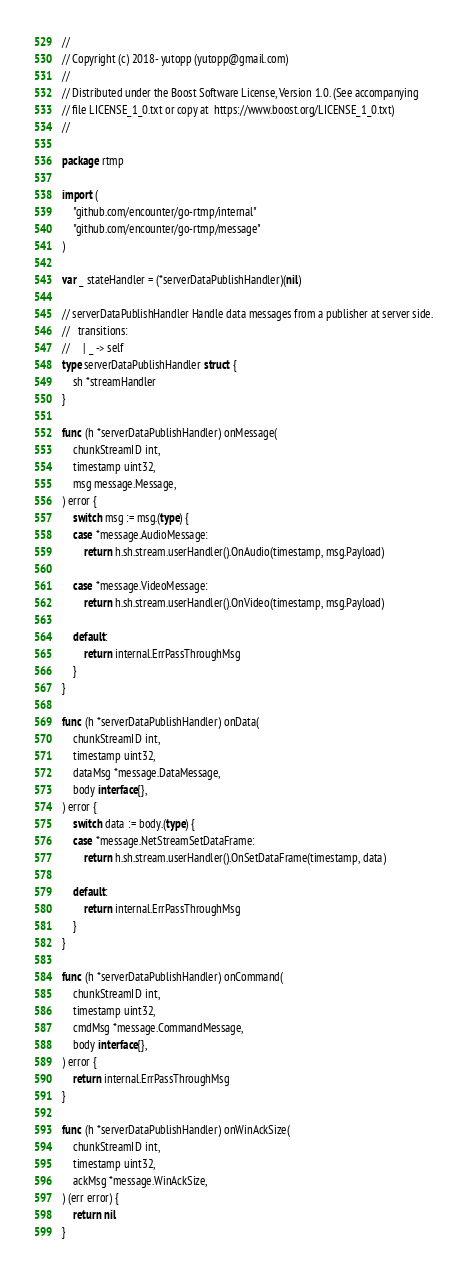Convert code to text. <code><loc_0><loc_0><loc_500><loc_500><_Go_>//
// Copyright (c) 2018- yutopp (yutopp@gmail.com)
//
// Distributed under the Boost Software License, Version 1.0. (See accompanying
// file LICENSE_1_0.txt or copy at  https://www.boost.org/LICENSE_1_0.txt)
//

package rtmp

import (
	"github.com/encounter/go-rtmp/internal"
	"github.com/encounter/go-rtmp/message"
)

var _ stateHandler = (*serverDataPublishHandler)(nil)

// serverDataPublishHandler Handle data messages from a publisher at server side.
//   transitions:
//     | _ -> self
type serverDataPublishHandler struct {
	sh *streamHandler
}

func (h *serverDataPublishHandler) onMessage(
	chunkStreamID int,
	timestamp uint32,
	msg message.Message,
) error {
	switch msg := msg.(type) {
	case *message.AudioMessage:
		return h.sh.stream.userHandler().OnAudio(timestamp, msg.Payload)

	case *message.VideoMessage:
		return h.sh.stream.userHandler().OnVideo(timestamp, msg.Payload)

	default:
		return internal.ErrPassThroughMsg
	}
}

func (h *serverDataPublishHandler) onData(
	chunkStreamID int,
	timestamp uint32,
	dataMsg *message.DataMessage,
	body interface{},
) error {
	switch data := body.(type) {
	case *message.NetStreamSetDataFrame:
		return h.sh.stream.userHandler().OnSetDataFrame(timestamp, data)

	default:
		return internal.ErrPassThroughMsg
	}
}

func (h *serverDataPublishHandler) onCommand(
	chunkStreamID int,
	timestamp uint32,
	cmdMsg *message.CommandMessage,
	body interface{},
) error {
	return internal.ErrPassThroughMsg
}

func (h *serverDataPublishHandler) onWinAckSize(
	chunkStreamID int,
	timestamp uint32,
	ackMsg *message.WinAckSize,
) (err error) {
	return nil
}
</code> 